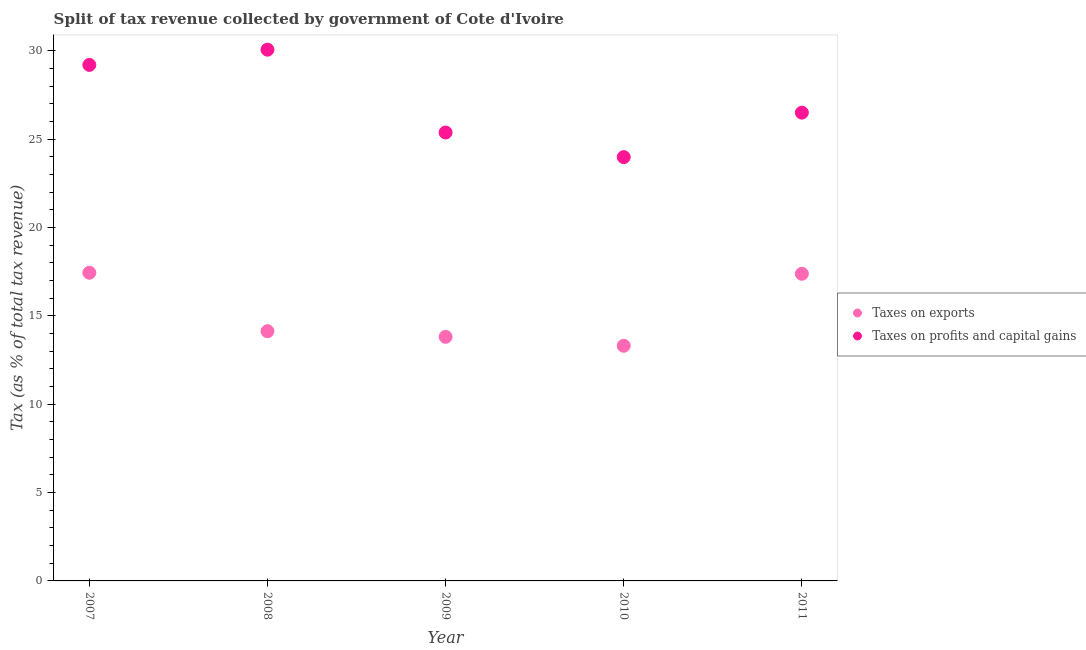How many different coloured dotlines are there?
Provide a succinct answer. 2. What is the percentage of revenue obtained from taxes on exports in 2008?
Your answer should be compact. 14.13. Across all years, what is the maximum percentage of revenue obtained from taxes on profits and capital gains?
Make the answer very short. 30.07. Across all years, what is the minimum percentage of revenue obtained from taxes on exports?
Make the answer very short. 13.31. What is the total percentage of revenue obtained from taxes on exports in the graph?
Offer a terse response. 76.09. What is the difference between the percentage of revenue obtained from taxes on profits and capital gains in 2009 and that in 2011?
Your answer should be very brief. -1.12. What is the difference between the percentage of revenue obtained from taxes on exports in 2011 and the percentage of revenue obtained from taxes on profits and capital gains in 2008?
Ensure brevity in your answer.  -12.68. What is the average percentage of revenue obtained from taxes on exports per year?
Your answer should be very brief. 15.22. In the year 2008, what is the difference between the percentage of revenue obtained from taxes on profits and capital gains and percentage of revenue obtained from taxes on exports?
Your answer should be compact. 15.93. In how many years, is the percentage of revenue obtained from taxes on profits and capital gains greater than 19 %?
Make the answer very short. 5. What is the ratio of the percentage of revenue obtained from taxes on profits and capital gains in 2008 to that in 2009?
Keep it short and to the point. 1.18. Is the difference between the percentage of revenue obtained from taxes on exports in 2008 and 2009 greater than the difference between the percentage of revenue obtained from taxes on profits and capital gains in 2008 and 2009?
Offer a very short reply. No. What is the difference between the highest and the second highest percentage of revenue obtained from taxes on exports?
Offer a very short reply. 0.06. What is the difference between the highest and the lowest percentage of revenue obtained from taxes on exports?
Make the answer very short. 4.13. In how many years, is the percentage of revenue obtained from taxes on profits and capital gains greater than the average percentage of revenue obtained from taxes on profits and capital gains taken over all years?
Ensure brevity in your answer.  2. Is the sum of the percentage of revenue obtained from taxes on exports in 2009 and 2011 greater than the maximum percentage of revenue obtained from taxes on profits and capital gains across all years?
Your answer should be compact. Yes. What is the difference between two consecutive major ticks on the Y-axis?
Ensure brevity in your answer.  5. Does the graph contain any zero values?
Keep it short and to the point. No. How many legend labels are there?
Ensure brevity in your answer.  2. What is the title of the graph?
Give a very brief answer. Split of tax revenue collected by government of Cote d'Ivoire. Does "Netherlands" appear as one of the legend labels in the graph?
Provide a short and direct response. No. What is the label or title of the Y-axis?
Offer a very short reply. Tax (as % of total tax revenue). What is the Tax (as % of total tax revenue) in Taxes on exports in 2007?
Your answer should be very brief. 17.44. What is the Tax (as % of total tax revenue) in Taxes on profits and capital gains in 2007?
Ensure brevity in your answer.  29.21. What is the Tax (as % of total tax revenue) of Taxes on exports in 2008?
Keep it short and to the point. 14.13. What is the Tax (as % of total tax revenue) in Taxes on profits and capital gains in 2008?
Give a very brief answer. 30.07. What is the Tax (as % of total tax revenue) in Taxes on exports in 2009?
Make the answer very short. 13.81. What is the Tax (as % of total tax revenue) in Taxes on profits and capital gains in 2009?
Your answer should be compact. 25.38. What is the Tax (as % of total tax revenue) in Taxes on exports in 2010?
Your answer should be very brief. 13.31. What is the Tax (as % of total tax revenue) in Taxes on profits and capital gains in 2010?
Make the answer very short. 23.99. What is the Tax (as % of total tax revenue) of Taxes on exports in 2011?
Provide a short and direct response. 17.38. What is the Tax (as % of total tax revenue) of Taxes on profits and capital gains in 2011?
Your answer should be very brief. 26.5. Across all years, what is the maximum Tax (as % of total tax revenue) of Taxes on exports?
Ensure brevity in your answer.  17.44. Across all years, what is the maximum Tax (as % of total tax revenue) of Taxes on profits and capital gains?
Provide a succinct answer. 30.07. Across all years, what is the minimum Tax (as % of total tax revenue) in Taxes on exports?
Make the answer very short. 13.31. Across all years, what is the minimum Tax (as % of total tax revenue) of Taxes on profits and capital gains?
Offer a very short reply. 23.99. What is the total Tax (as % of total tax revenue) in Taxes on exports in the graph?
Ensure brevity in your answer.  76.09. What is the total Tax (as % of total tax revenue) in Taxes on profits and capital gains in the graph?
Ensure brevity in your answer.  135.14. What is the difference between the Tax (as % of total tax revenue) in Taxes on exports in 2007 and that in 2008?
Give a very brief answer. 3.31. What is the difference between the Tax (as % of total tax revenue) in Taxes on profits and capital gains in 2007 and that in 2008?
Your response must be concise. -0.86. What is the difference between the Tax (as % of total tax revenue) in Taxes on exports in 2007 and that in 2009?
Provide a short and direct response. 3.63. What is the difference between the Tax (as % of total tax revenue) of Taxes on profits and capital gains in 2007 and that in 2009?
Offer a very short reply. 3.83. What is the difference between the Tax (as % of total tax revenue) of Taxes on exports in 2007 and that in 2010?
Ensure brevity in your answer.  4.13. What is the difference between the Tax (as % of total tax revenue) in Taxes on profits and capital gains in 2007 and that in 2010?
Give a very brief answer. 5.22. What is the difference between the Tax (as % of total tax revenue) of Taxes on exports in 2007 and that in 2011?
Your answer should be very brief. 0.06. What is the difference between the Tax (as % of total tax revenue) in Taxes on profits and capital gains in 2007 and that in 2011?
Make the answer very short. 2.7. What is the difference between the Tax (as % of total tax revenue) of Taxes on exports in 2008 and that in 2009?
Provide a succinct answer. 0.32. What is the difference between the Tax (as % of total tax revenue) of Taxes on profits and capital gains in 2008 and that in 2009?
Your answer should be compact. 4.69. What is the difference between the Tax (as % of total tax revenue) in Taxes on exports in 2008 and that in 2010?
Give a very brief answer. 0.82. What is the difference between the Tax (as % of total tax revenue) in Taxes on profits and capital gains in 2008 and that in 2010?
Your answer should be very brief. 6.08. What is the difference between the Tax (as % of total tax revenue) of Taxes on exports in 2008 and that in 2011?
Give a very brief answer. -3.25. What is the difference between the Tax (as % of total tax revenue) of Taxes on profits and capital gains in 2008 and that in 2011?
Give a very brief answer. 3.56. What is the difference between the Tax (as % of total tax revenue) in Taxes on exports in 2009 and that in 2010?
Your answer should be compact. 0.5. What is the difference between the Tax (as % of total tax revenue) in Taxes on profits and capital gains in 2009 and that in 2010?
Provide a short and direct response. 1.39. What is the difference between the Tax (as % of total tax revenue) in Taxes on exports in 2009 and that in 2011?
Make the answer very short. -3.57. What is the difference between the Tax (as % of total tax revenue) of Taxes on profits and capital gains in 2009 and that in 2011?
Your answer should be very brief. -1.12. What is the difference between the Tax (as % of total tax revenue) of Taxes on exports in 2010 and that in 2011?
Provide a short and direct response. -4.07. What is the difference between the Tax (as % of total tax revenue) in Taxes on profits and capital gains in 2010 and that in 2011?
Offer a terse response. -2.52. What is the difference between the Tax (as % of total tax revenue) in Taxes on exports in 2007 and the Tax (as % of total tax revenue) in Taxes on profits and capital gains in 2008?
Ensure brevity in your answer.  -12.62. What is the difference between the Tax (as % of total tax revenue) in Taxes on exports in 2007 and the Tax (as % of total tax revenue) in Taxes on profits and capital gains in 2009?
Provide a short and direct response. -7.94. What is the difference between the Tax (as % of total tax revenue) of Taxes on exports in 2007 and the Tax (as % of total tax revenue) of Taxes on profits and capital gains in 2010?
Provide a short and direct response. -6.54. What is the difference between the Tax (as % of total tax revenue) in Taxes on exports in 2007 and the Tax (as % of total tax revenue) in Taxes on profits and capital gains in 2011?
Offer a terse response. -9.06. What is the difference between the Tax (as % of total tax revenue) of Taxes on exports in 2008 and the Tax (as % of total tax revenue) of Taxes on profits and capital gains in 2009?
Ensure brevity in your answer.  -11.25. What is the difference between the Tax (as % of total tax revenue) of Taxes on exports in 2008 and the Tax (as % of total tax revenue) of Taxes on profits and capital gains in 2010?
Offer a terse response. -9.85. What is the difference between the Tax (as % of total tax revenue) of Taxes on exports in 2008 and the Tax (as % of total tax revenue) of Taxes on profits and capital gains in 2011?
Offer a terse response. -12.37. What is the difference between the Tax (as % of total tax revenue) of Taxes on exports in 2009 and the Tax (as % of total tax revenue) of Taxes on profits and capital gains in 2010?
Offer a terse response. -10.17. What is the difference between the Tax (as % of total tax revenue) of Taxes on exports in 2009 and the Tax (as % of total tax revenue) of Taxes on profits and capital gains in 2011?
Your response must be concise. -12.69. What is the difference between the Tax (as % of total tax revenue) in Taxes on exports in 2010 and the Tax (as % of total tax revenue) in Taxes on profits and capital gains in 2011?
Ensure brevity in your answer.  -13.19. What is the average Tax (as % of total tax revenue) of Taxes on exports per year?
Your answer should be compact. 15.22. What is the average Tax (as % of total tax revenue) in Taxes on profits and capital gains per year?
Offer a terse response. 27.03. In the year 2007, what is the difference between the Tax (as % of total tax revenue) in Taxes on exports and Tax (as % of total tax revenue) in Taxes on profits and capital gains?
Ensure brevity in your answer.  -11.76. In the year 2008, what is the difference between the Tax (as % of total tax revenue) of Taxes on exports and Tax (as % of total tax revenue) of Taxes on profits and capital gains?
Your answer should be very brief. -15.93. In the year 2009, what is the difference between the Tax (as % of total tax revenue) of Taxes on exports and Tax (as % of total tax revenue) of Taxes on profits and capital gains?
Your response must be concise. -11.56. In the year 2010, what is the difference between the Tax (as % of total tax revenue) in Taxes on exports and Tax (as % of total tax revenue) in Taxes on profits and capital gains?
Your response must be concise. -10.68. In the year 2011, what is the difference between the Tax (as % of total tax revenue) of Taxes on exports and Tax (as % of total tax revenue) of Taxes on profits and capital gains?
Your response must be concise. -9.12. What is the ratio of the Tax (as % of total tax revenue) of Taxes on exports in 2007 to that in 2008?
Your answer should be very brief. 1.23. What is the ratio of the Tax (as % of total tax revenue) of Taxes on profits and capital gains in 2007 to that in 2008?
Keep it short and to the point. 0.97. What is the ratio of the Tax (as % of total tax revenue) in Taxes on exports in 2007 to that in 2009?
Offer a very short reply. 1.26. What is the ratio of the Tax (as % of total tax revenue) of Taxes on profits and capital gains in 2007 to that in 2009?
Provide a succinct answer. 1.15. What is the ratio of the Tax (as % of total tax revenue) in Taxes on exports in 2007 to that in 2010?
Your answer should be compact. 1.31. What is the ratio of the Tax (as % of total tax revenue) in Taxes on profits and capital gains in 2007 to that in 2010?
Provide a succinct answer. 1.22. What is the ratio of the Tax (as % of total tax revenue) in Taxes on profits and capital gains in 2007 to that in 2011?
Offer a very short reply. 1.1. What is the ratio of the Tax (as % of total tax revenue) of Taxes on exports in 2008 to that in 2009?
Your response must be concise. 1.02. What is the ratio of the Tax (as % of total tax revenue) in Taxes on profits and capital gains in 2008 to that in 2009?
Offer a very short reply. 1.18. What is the ratio of the Tax (as % of total tax revenue) in Taxes on exports in 2008 to that in 2010?
Give a very brief answer. 1.06. What is the ratio of the Tax (as % of total tax revenue) of Taxes on profits and capital gains in 2008 to that in 2010?
Offer a terse response. 1.25. What is the ratio of the Tax (as % of total tax revenue) in Taxes on exports in 2008 to that in 2011?
Keep it short and to the point. 0.81. What is the ratio of the Tax (as % of total tax revenue) in Taxes on profits and capital gains in 2008 to that in 2011?
Provide a short and direct response. 1.13. What is the ratio of the Tax (as % of total tax revenue) in Taxes on exports in 2009 to that in 2010?
Your answer should be compact. 1.04. What is the ratio of the Tax (as % of total tax revenue) of Taxes on profits and capital gains in 2009 to that in 2010?
Ensure brevity in your answer.  1.06. What is the ratio of the Tax (as % of total tax revenue) of Taxes on exports in 2009 to that in 2011?
Keep it short and to the point. 0.79. What is the ratio of the Tax (as % of total tax revenue) in Taxes on profits and capital gains in 2009 to that in 2011?
Offer a very short reply. 0.96. What is the ratio of the Tax (as % of total tax revenue) of Taxes on exports in 2010 to that in 2011?
Ensure brevity in your answer.  0.77. What is the ratio of the Tax (as % of total tax revenue) in Taxes on profits and capital gains in 2010 to that in 2011?
Your answer should be very brief. 0.91. What is the difference between the highest and the second highest Tax (as % of total tax revenue) in Taxes on exports?
Your response must be concise. 0.06. What is the difference between the highest and the second highest Tax (as % of total tax revenue) of Taxes on profits and capital gains?
Make the answer very short. 0.86. What is the difference between the highest and the lowest Tax (as % of total tax revenue) of Taxes on exports?
Keep it short and to the point. 4.13. What is the difference between the highest and the lowest Tax (as % of total tax revenue) in Taxes on profits and capital gains?
Your response must be concise. 6.08. 